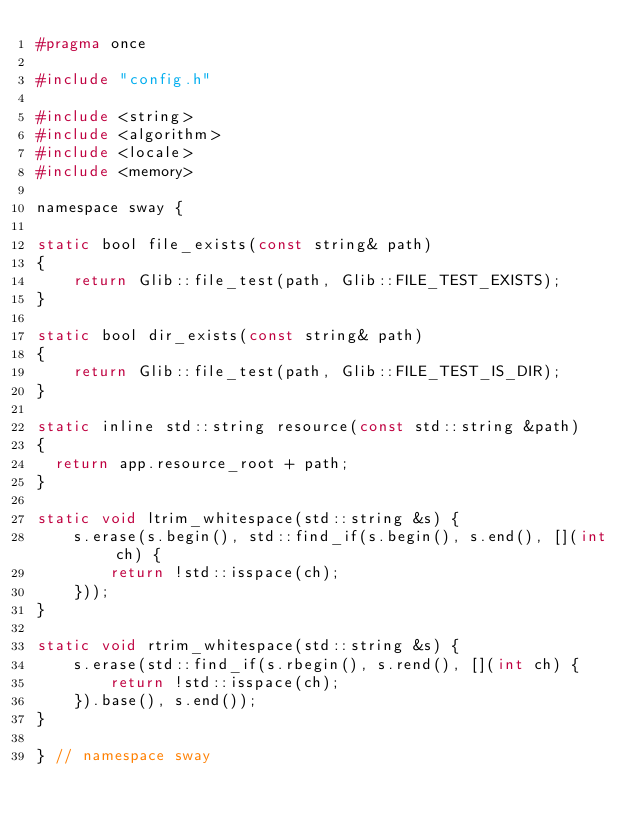<code> <loc_0><loc_0><loc_500><loc_500><_C_>#pragma once 

#include "config.h"

#include <string>
#include <algorithm>
#include <locale>
#include <memory>

namespace sway {

static bool file_exists(const string& path)
{
    return Glib::file_test(path, Glib::FILE_TEST_EXISTS);
}

static bool dir_exists(const string& path)
{
    return Glib::file_test(path, Glib::FILE_TEST_IS_DIR);
}

static inline std::string resource(const std::string &path)
{
  return app.resource_root + path;
}

static void ltrim_whitespace(std::string &s) {
    s.erase(s.begin(), std::find_if(s.begin(), s.end(), [](int ch) {
        return !std::isspace(ch);
    }));
}

static void rtrim_whitespace(std::string &s) {
    s.erase(std::find_if(s.rbegin(), s.rend(), [](int ch) {
        return !std::isspace(ch);
    }).base(), s.end());
}

} // namespace sway 
</code> 